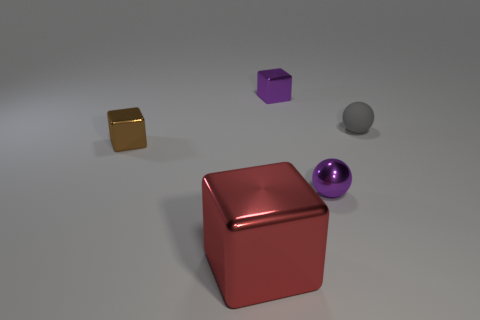Subtract all small brown metallic blocks. How many blocks are left? 2 Subtract all gray spheres. How many spheres are left? 1 Subtract all blocks. How many objects are left? 2 Subtract 3 blocks. How many blocks are left? 0 Add 2 large green matte objects. How many objects exist? 7 Subtract all green cubes. How many gray spheres are left? 1 Add 3 small purple metal balls. How many small purple metal balls are left? 4 Add 4 tiny shiny balls. How many tiny shiny balls exist? 5 Subtract 0 purple cylinders. How many objects are left? 5 Subtract all green balls. Subtract all yellow cubes. How many balls are left? 2 